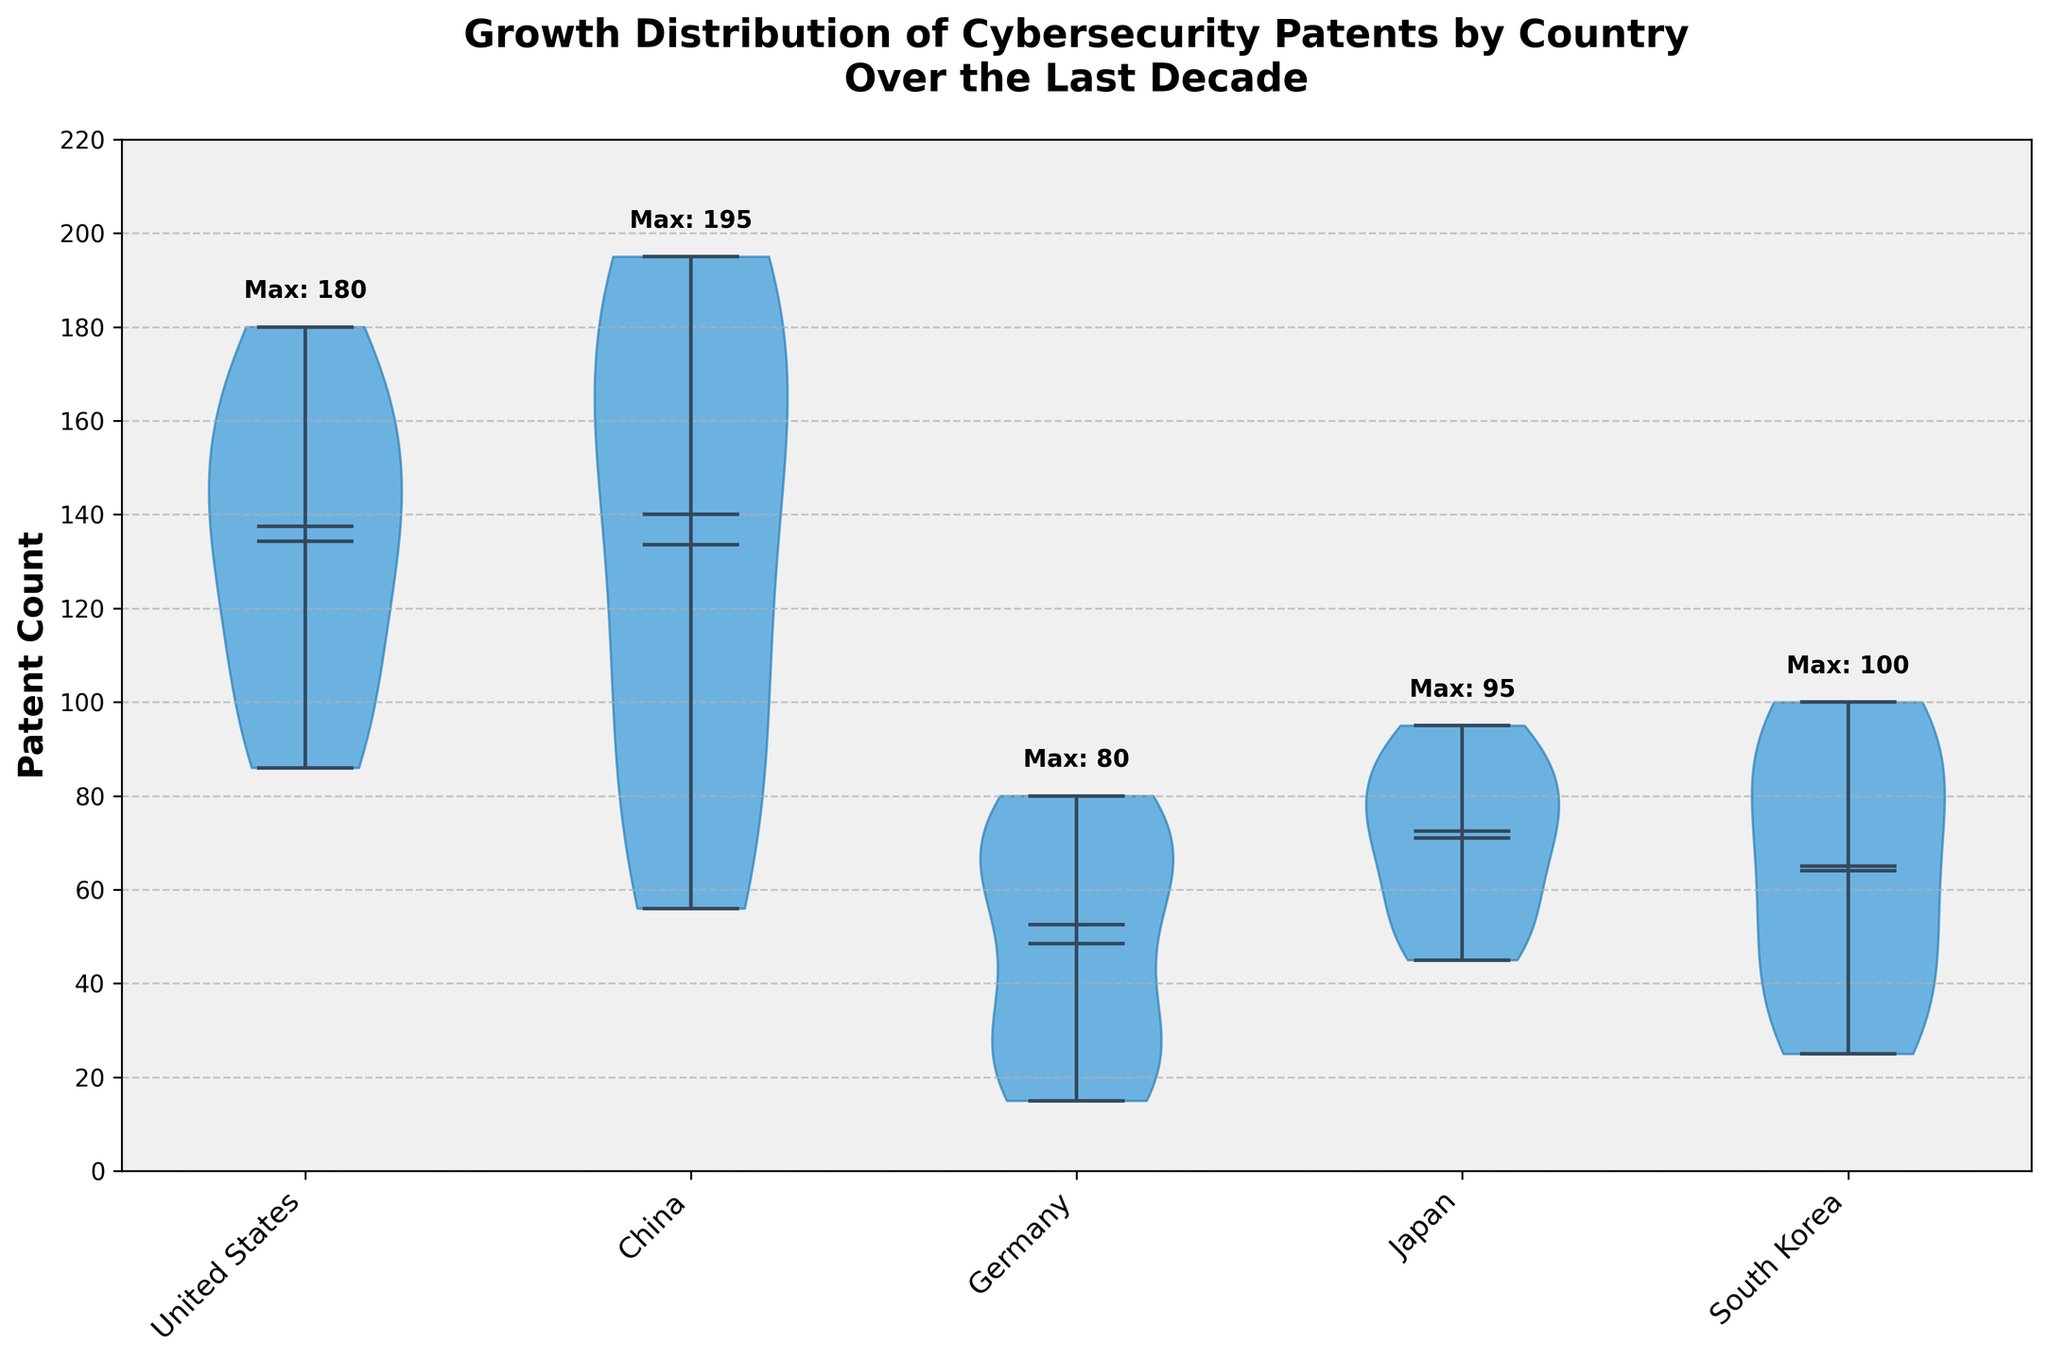How many countries are compared in the figure? The x-axis has distinct labels for each country, and each country has a separate violin plot. By counting these labels, we can determine the number of countries compared.
Answer: 5 Which country has the highest maximum patent count? Each violin plot is annotated with the maximum patent count of that country above the plot. By comparing these annotations, we can determine which country has the highest maximum patent count.
Answer: United States What is the range of patent counts for Germany? The extremes of Germany’s violin plot, marked by the minimum and maximum values, show the range. The minimum patent count is 15, and the maximum is 80.
Answer: 15 to 80 How does the median patent count for South Korea compare to that of Japan? The medians of the violin plots are marked by horizontal lines. We can visually compare the median for South Korea and Japan along the y-axis to see which is higher.
Answer: South Korea has a higher median patent count than Japan What trend does the distribution of patent counts for China show? The shape of the violin plot for China and the spread of the distribution help us understand trends. The distribution for China shows a consistent increase over time, indicated by the wider spread towards higher values.
Answer: Increasing trend Which country has the narrowest distribution of patent counts, indicating the least variability? The width of the violin plot indicates variability. The country with the narrowest violin plot has the least variability in patent counts over the decade.
Answer: Japan How do the average patent counts compare between the United States and Germany? The average is indicated by a marker within the violin plot. We can visually compare these markers for the United States and Germany to see which has a higher average patent count.
Answer: The United States has a higher average patent count than Germany What unique insight does the violin plot provide about the patent counts over a box plot? Unlike a box plot, a violin plot shows the full distribution of the data, allowing insights into the density and variability of patent counts, not just the median and quartiles.
Answer: Density and variability of data Why might it be important to consider the distribution of these patent counts rather than just the means or medians? Considering the distribution provides a complete picture of data variability and density, which can highlight outliers, trends, and the overall spread, giving more context than just means or medians.
Answer: Complete data picture and context What could be a potential reason for the annotation of the maximum values above each violin plot? The maximum values provide immediate insight into the upper bounds of patent counts, making it easier to compare the extent of growth among different countries at a glance.
Answer: Comparability of growth 